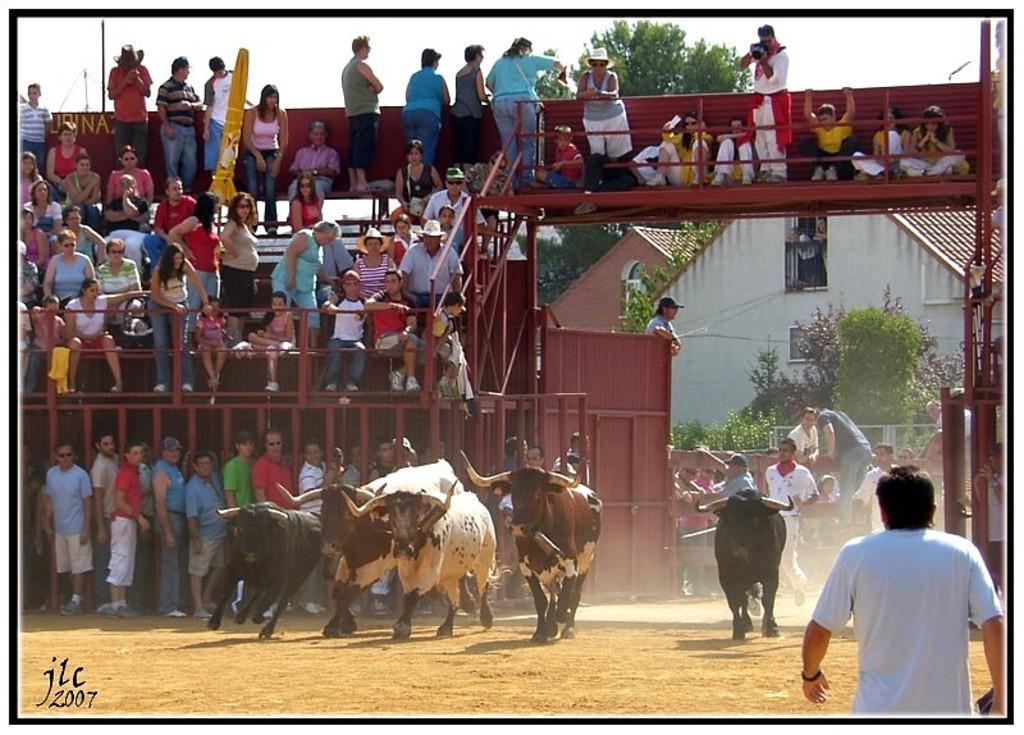How would you summarize this image in a sentence or two? This is an edited image. I can see groups of people standing and groups of people sitting on the benches. At the bottom of the image, there are bulls running. I can see an iron gate. In the background, there are buildings, trees and the sky. At the bottom left corner of the image, I can see a watermark. 